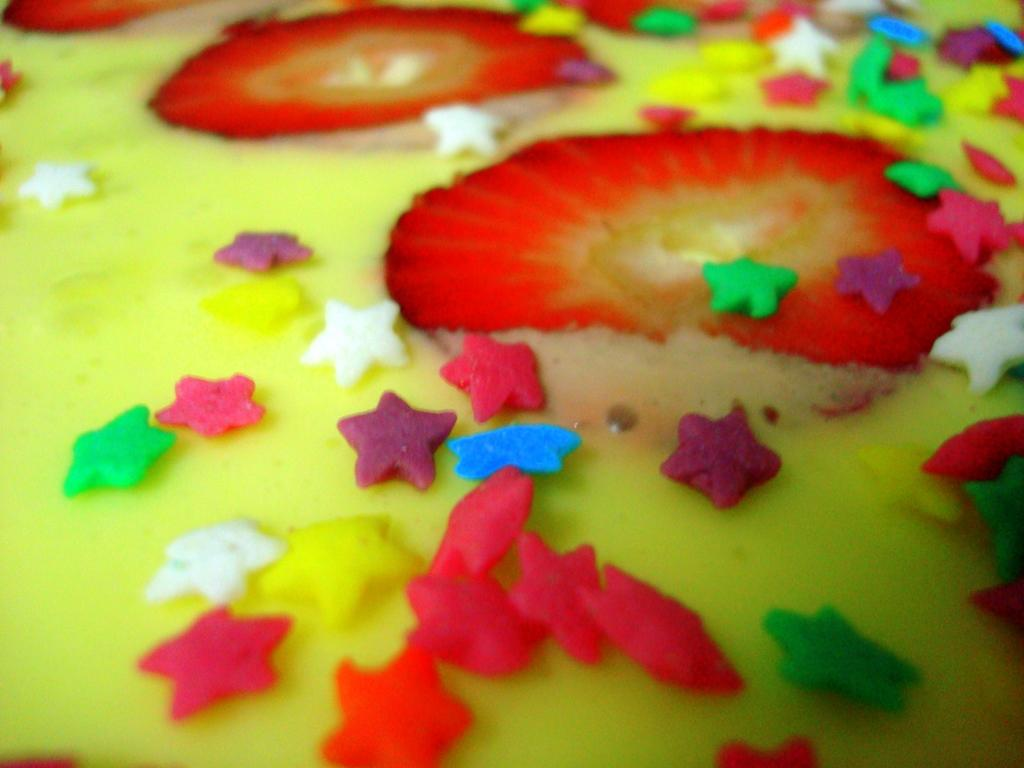What is the main subject of the image? The main subject of the image is food. Can you describe the appearance of the food? The food has colorful toppings. What time of day does the image depict? The time of day is not mentioned or depicted in the image. Is there a slope in the image? There is no slope present in the image. 